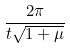Convert formula to latex. <formula><loc_0><loc_0><loc_500><loc_500>\frac { 2 \pi } { t \sqrt { 1 + \mu } }</formula> 